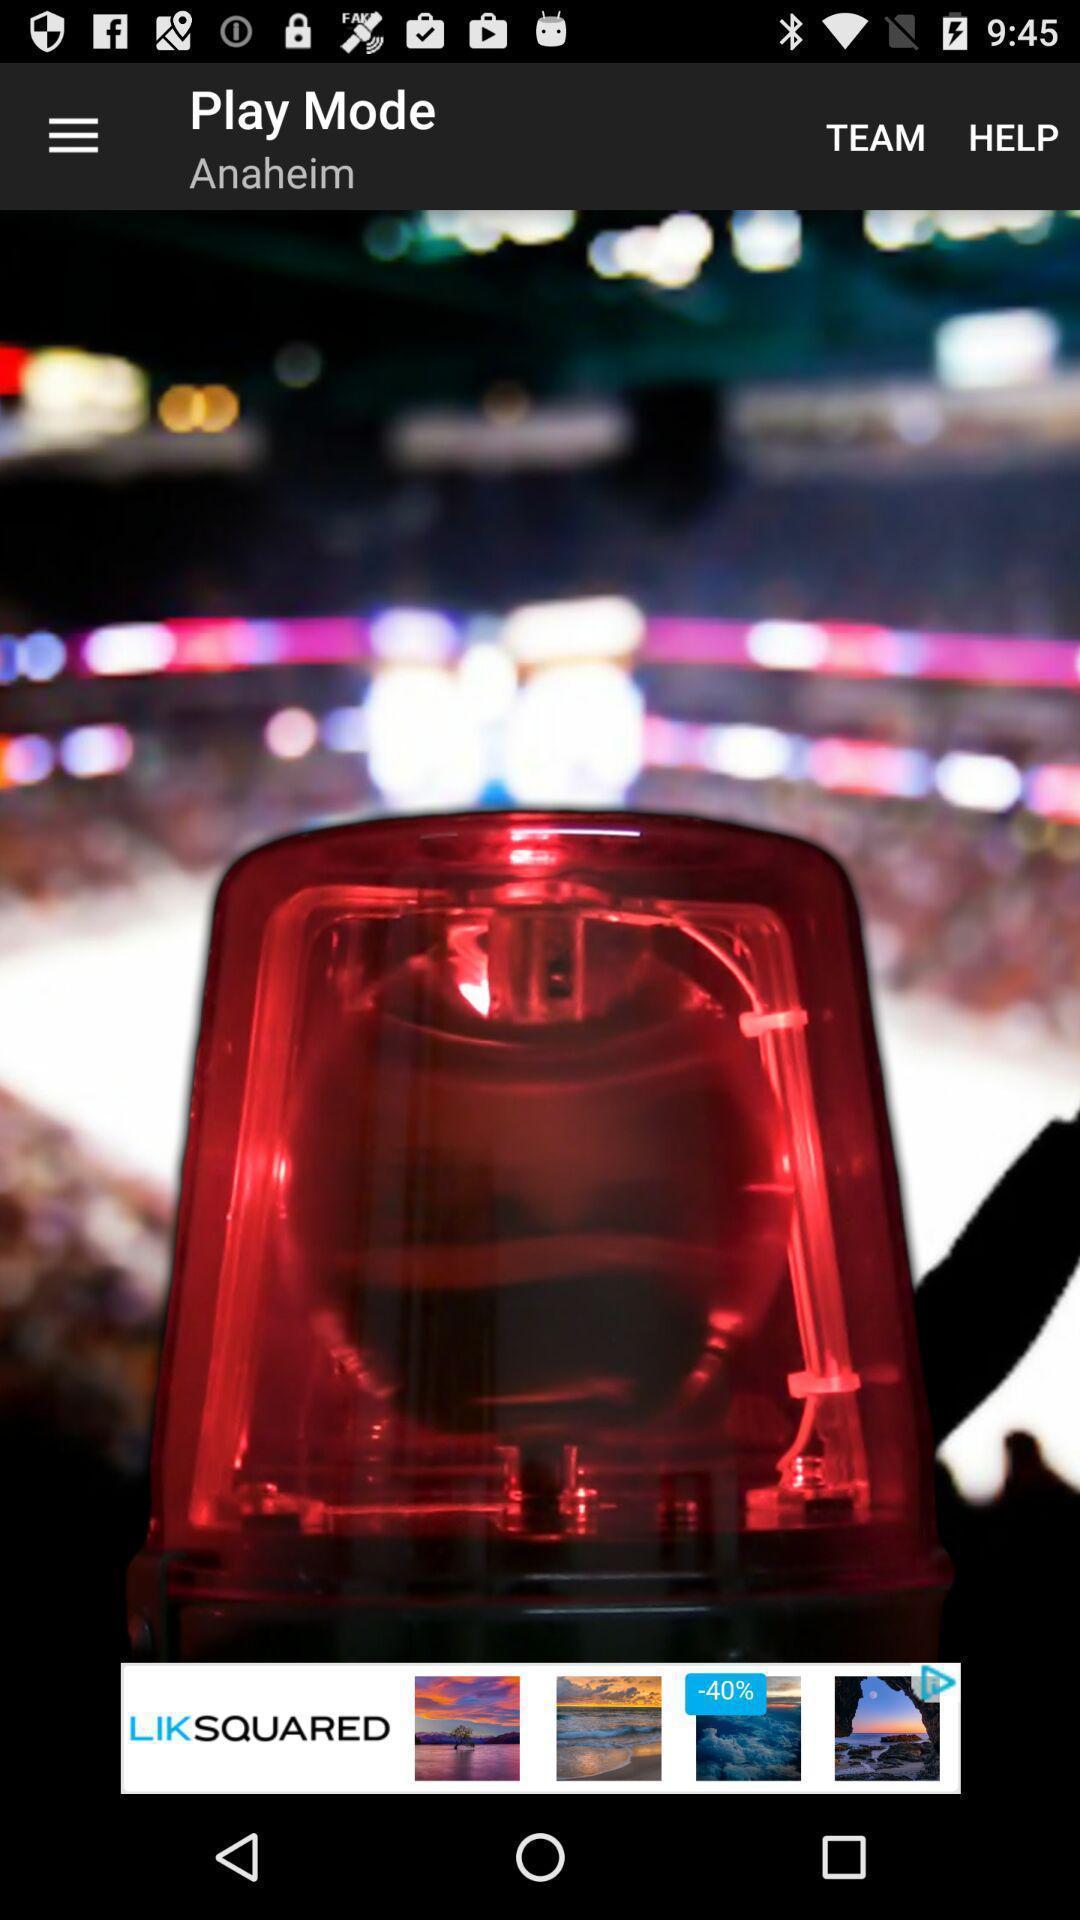Give me a narrative description of this picture. Screen displaying the welcome page of sports app. 